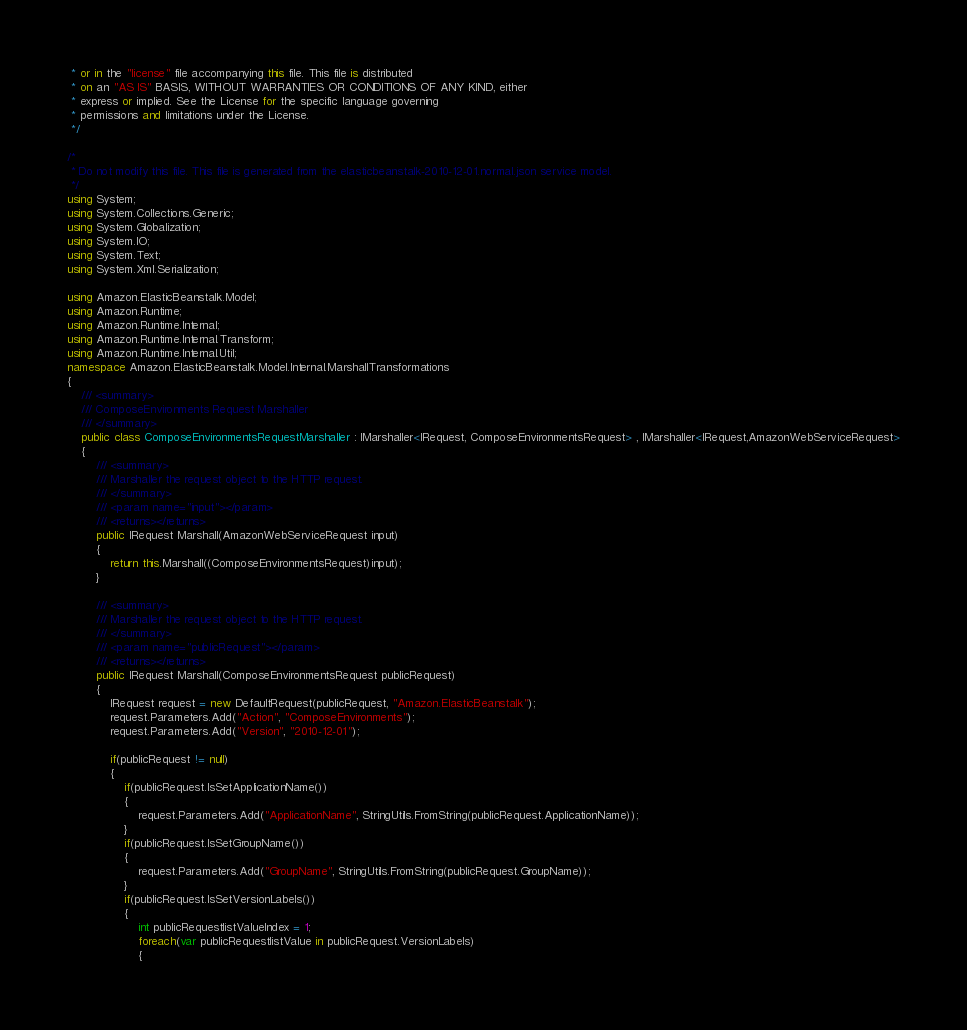Convert code to text. <code><loc_0><loc_0><loc_500><loc_500><_C#_> * or in the "license" file accompanying this file. This file is distributed
 * on an "AS IS" BASIS, WITHOUT WARRANTIES OR CONDITIONS OF ANY KIND, either
 * express or implied. See the License for the specific language governing
 * permissions and limitations under the License.
 */

/*
 * Do not modify this file. This file is generated from the elasticbeanstalk-2010-12-01.normal.json service model.
 */
using System;
using System.Collections.Generic;
using System.Globalization;
using System.IO;
using System.Text;
using System.Xml.Serialization;

using Amazon.ElasticBeanstalk.Model;
using Amazon.Runtime;
using Amazon.Runtime.Internal;
using Amazon.Runtime.Internal.Transform;
using Amazon.Runtime.Internal.Util;
namespace Amazon.ElasticBeanstalk.Model.Internal.MarshallTransformations
{
    /// <summary>
    /// ComposeEnvironments Request Marshaller
    /// </summary>       
    public class ComposeEnvironmentsRequestMarshaller : IMarshaller<IRequest, ComposeEnvironmentsRequest> , IMarshaller<IRequest,AmazonWebServiceRequest>
    {
        /// <summary>
        /// Marshaller the request object to the HTTP request.
        /// </summary>  
        /// <param name="input"></param>
        /// <returns></returns>
        public IRequest Marshall(AmazonWebServiceRequest input)
        {
            return this.Marshall((ComposeEnvironmentsRequest)input);
        }
    
        /// <summary>
        /// Marshaller the request object to the HTTP request.
        /// </summary>  
        /// <param name="publicRequest"></param>
        /// <returns></returns>
        public IRequest Marshall(ComposeEnvironmentsRequest publicRequest)
        {
            IRequest request = new DefaultRequest(publicRequest, "Amazon.ElasticBeanstalk");
            request.Parameters.Add("Action", "ComposeEnvironments");
            request.Parameters.Add("Version", "2010-12-01");

            if(publicRequest != null)
            {
                if(publicRequest.IsSetApplicationName())
                {
                    request.Parameters.Add("ApplicationName", StringUtils.FromString(publicRequest.ApplicationName));
                }
                if(publicRequest.IsSetGroupName())
                {
                    request.Parameters.Add("GroupName", StringUtils.FromString(publicRequest.GroupName));
                }
                if(publicRequest.IsSetVersionLabels())
                {
                    int publicRequestlistValueIndex = 1;
                    foreach(var publicRequestlistValue in publicRequest.VersionLabels)
                    {</code> 